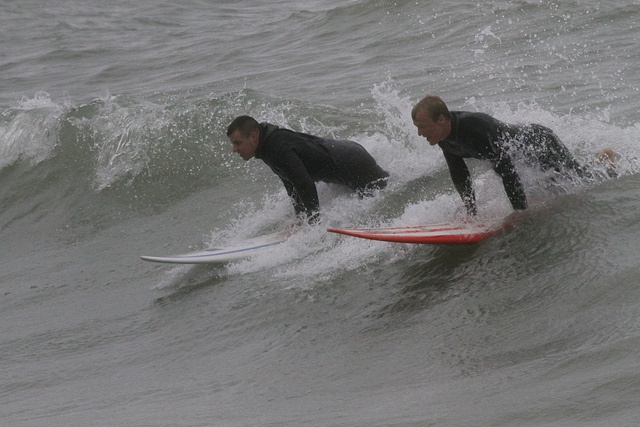Describe the objects in this image and their specific colors. I can see people in gray and black tones, people in gray and black tones, surfboard in gray, darkgray, and maroon tones, and surfboard in gray and darkgray tones in this image. 